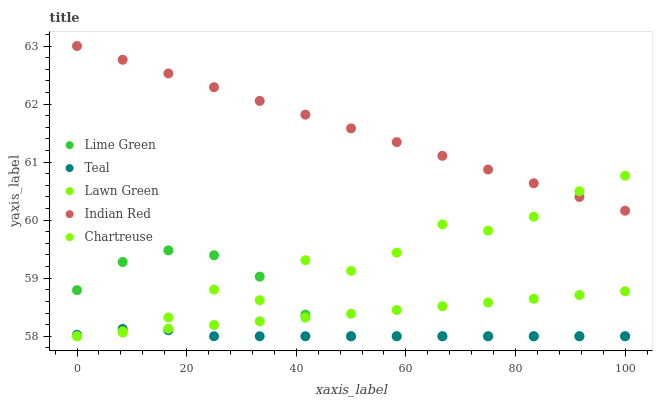Does Teal have the minimum area under the curve?
Answer yes or no. Yes. Does Indian Red have the maximum area under the curve?
Answer yes or no. Yes. Does Chartreuse have the minimum area under the curve?
Answer yes or no. No. Does Chartreuse have the maximum area under the curve?
Answer yes or no. No. Is Indian Red the smoothest?
Answer yes or no. Yes. Is Chartreuse the roughest?
Answer yes or no. Yes. Is Lime Green the smoothest?
Answer yes or no. No. Is Lime Green the roughest?
Answer yes or no. No. Does Lawn Green have the lowest value?
Answer yes or no. Yes. Does Indian Red have the lowest value?
Answer yes or no. No. Does Indian Red have the highest value?
Answer yes or no. Yes. Does Chartreuse have the highest value?
Answer yes or no. No. Is Teal less than Indian Red?
Answer yes or no. Yes. Is Indian Red greater than Teal?
Answer yes or no. Yes. Does Chartreuse intersect Teal?
Answer yes or no. Yes. Is Chartreuse less than Teal?
Answer yes or no. No. Is Chartreuse greater than Teal?
Answer yes or no. No. Does Teal intersect Indian Red?
Answer yes or no. No. 